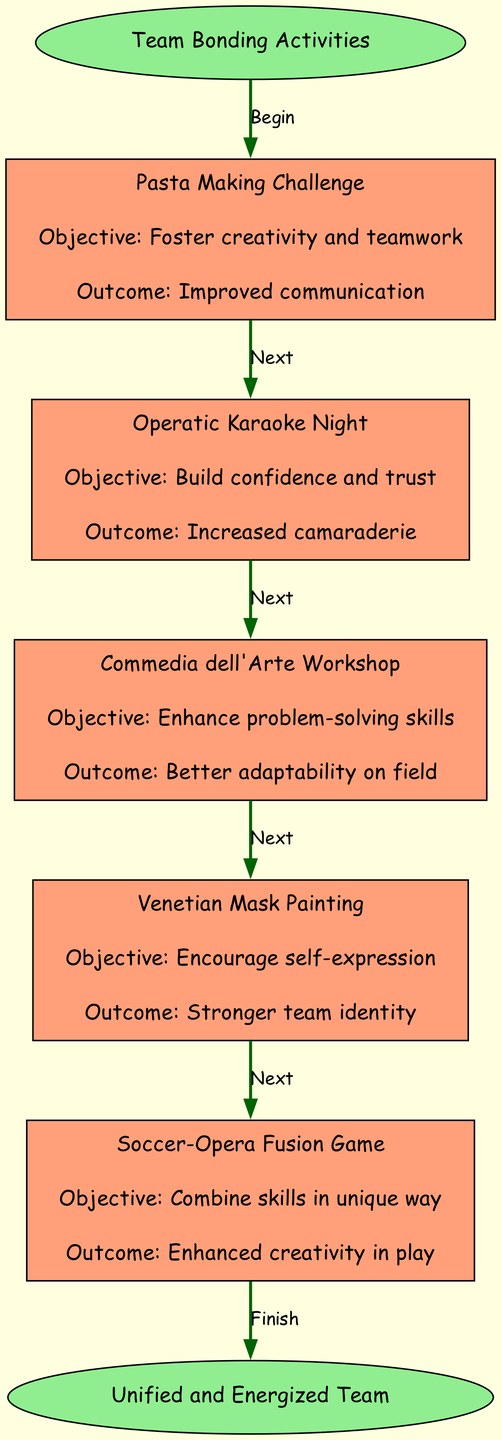What is the starting point of the activities flowchart? The starting point of the activities flowchart is indicated as the node labeled "Team Bonding Activities." This node is connected to the first activity, thus making it the origin of the flow.
Answer: Team Bonding Activities What is the last activity before reaching the end node? The last activity before reaching the end node is the one labeled "Soccer-Opera Fusion Game." It is the final activity node linked to the end node labeled "Unified and Energized Team."
Answer: Soccer-Opera Fusion Game How many activities are listed in the flowchart? The number of activities is determined by counting the individual activity nodes present in the diagram. There are five distinct activities shown.
Answer: Five What is the objective of the "Operatic Karaoke Night"? The objective for the "Operatic Karaoke Night" is explicitly stated in the diagram as "Build confidence and trust." This is a key part of the activity node details providing clarity on its purpose.
Answer: Build confidence and trust Which activity aims to encourage self-expression? The activity that aims to encourage self-expression is the one labeled "Venetian Mask Painting." The diagram specifies this objective directly within the activity node's details.
Answer: Venetian Mask Painting What is the final outcome expected after all activities? The final outcome expected after all activities, as indicated at the end of the flowchart, is labeled "Unified and Energized Team." This summarizes the overall goal of the team bonding activities.
Answer: Unified and Energized Team How does the "Commedia dell'Arte Workshop" contribute to the team's adaptability? The "Commedia dell'Arte Workshop" is designed with the objective to "Enhance problem-solving skills," which directly contributes to the expected outcome of "Better adaptability on field." Thus, it connects skills development with practical adaptability.
Answer: Better adaptability on field What type of diagram is being represented? The diagram being represented is a flowchart specifically designed to show the flow of activities related to team bonding. The structure highlights individual activities along with their objectives and expected outcomes.
Answer: Flowchart What color represents the activity nodes in the diagram? The color used to represent the activity nodes in the diagram is "lightsalmon," which is applied uniformly to all the activity nodes within the flowchart.
Answer: Lightsalmon 